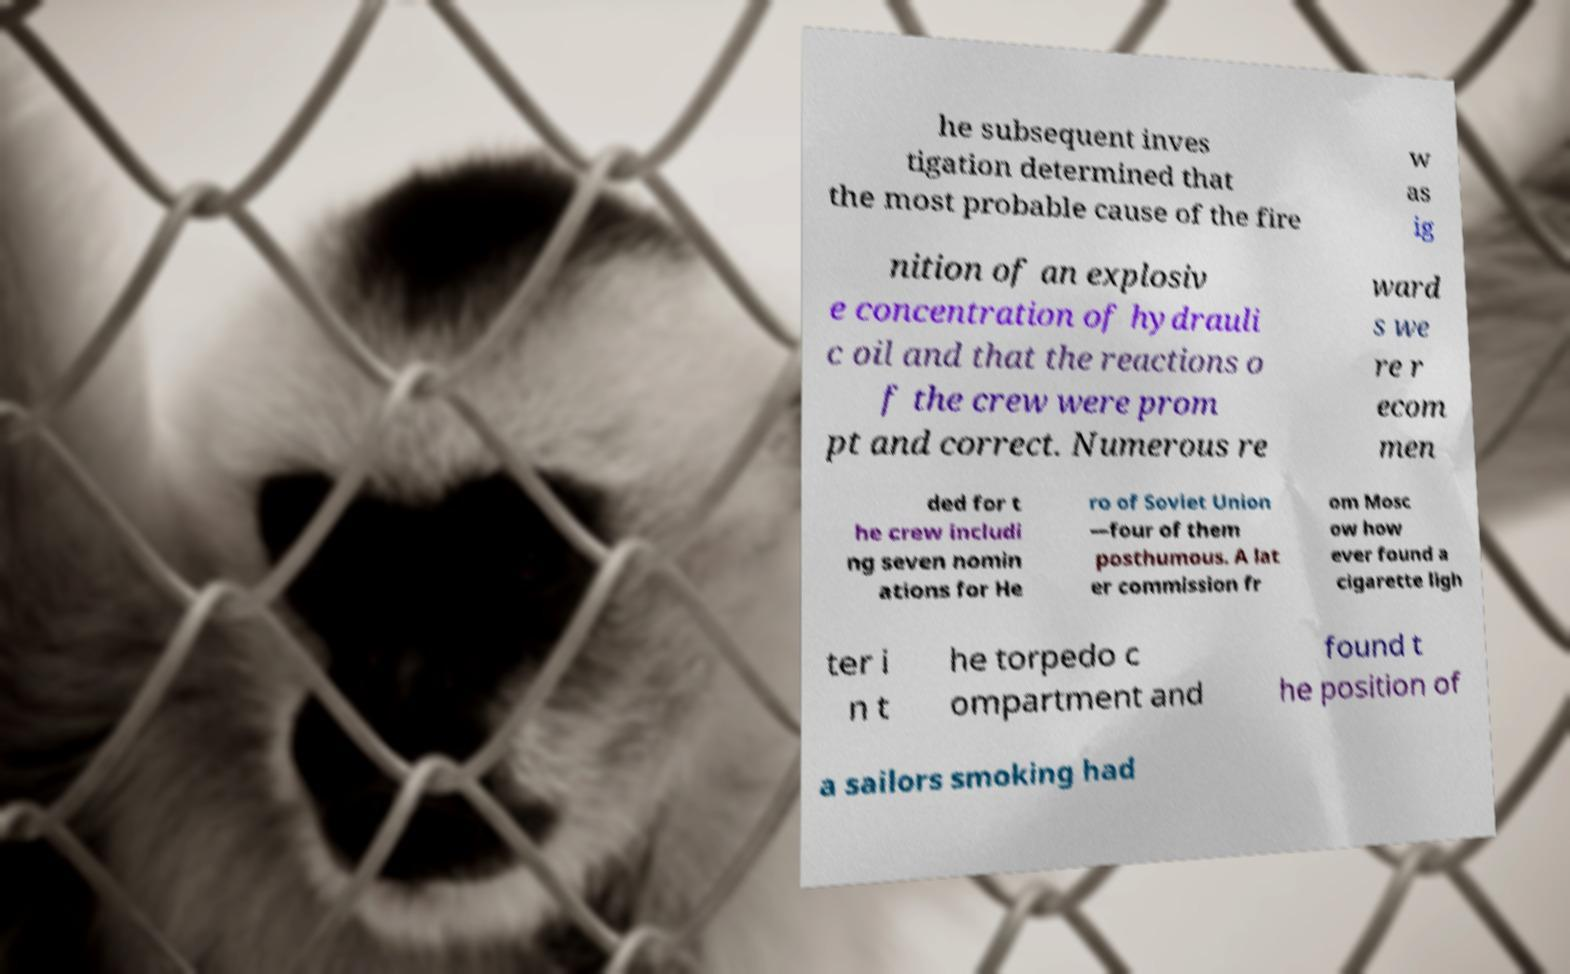Can you read and provide the text displayed in the image?This photo seems to have some interesting text. Can you extract and type it out for me? he subsequent inves tigation determined that the most probable cause of the fire w as ig nition of an explosiv e concentration of hydrauli c oil and that the reactions o f the crew were prom pt and correct. Numerous re ward s we re r ecom men ded for t he crew includi ng seven nomin ations for He ro of Soviet Union —four of them posthumous. A lat er commission fr om Mosc ow how ever found a cigarette ligh ter i n t he torpedo c ompartment and found t he position of a sailors smoking had 